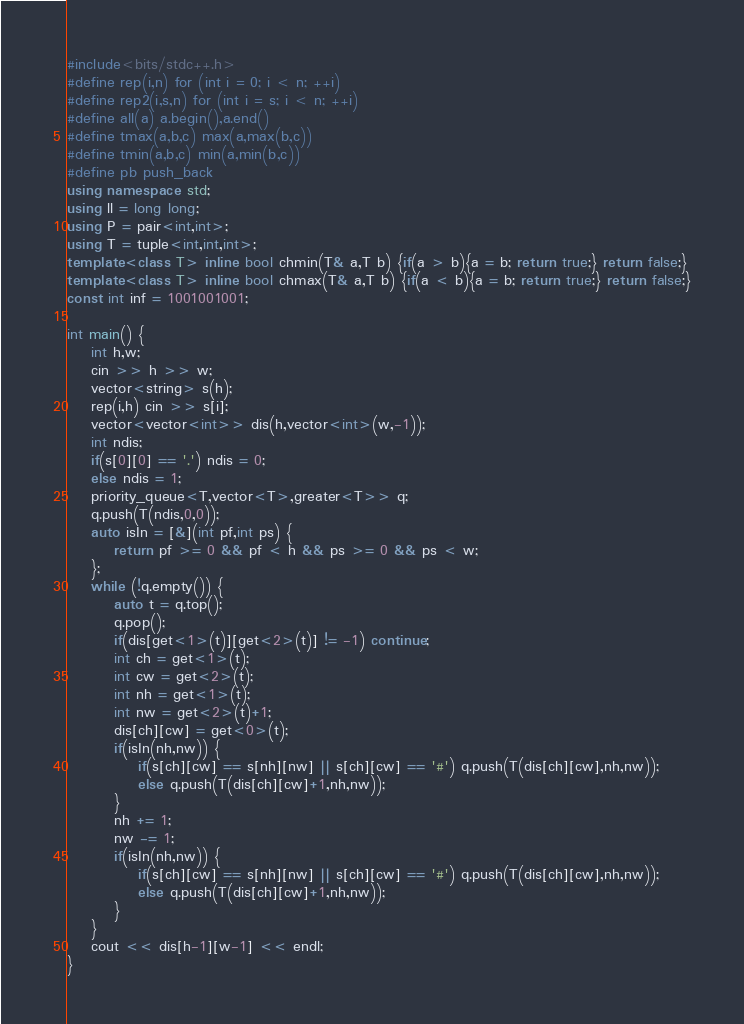Convert code to text. <code><loc_0><loc_0><loc_500><loc_500><_C++_>#include<bits/stdc++.h>
#define rep(i,n) for (int i = 0; i < n; ++i)
#define rep2(i,s,n) for (int i = s; i < n; ++i)
#define all(a) a.begin(),a.end()
#define tmax(a,b,c) max(a,max(b,c))
#define tmin(a,b,c) min(a,min(b,c))
#define pb push_back
using namespace std;
using ll = long long;
using P = pair<int,int>;
using T = tuple<int,int,int>;
template<class T> inline bool chmin(T& a,T b) {if(a > b){a = b; return true;} return false;}
template<class T> inline bool chmax(T& a,T b) {if(a < b){a = b; return true;} return false;}
const int inf = 1001001001;

int main() {
    int h,w;
    cin >> h >> w;
    vector<string> s(h);
    rep(i,h) cin >> s[i];
    vector<vector<int>> dis(h,vector<int>(w,-1));
    int ndis;
    if(s[0][0] == '.') ndis = 0;
    else ndis = 1;
    priority_queue<T,vector<T>,greater<T>> q;
    q.push(T(ndis,0,0));
    auto isIn = [&](int pf,int ps) {
        return pf >= 0 && pf < h && ps >= 0 && ps < w;
    };
    while (!q.empty()) {
        auto t = q.top();
        q.pop();
        if(dis[get<1>(t)][get<2>(t)] != -1) continue;
        int ch = get<1>(t);
        int cw = get<2>(t);
        int nh = get<1>(t);
        int nw = get<2>(t)+1;
        dis[ch][cw] = get<0>(t);
        if(isIn(nh,nw)) {
            if(s[ch][cw] == s[nh][nw] || s[ch][cw] == '#') q.push(T(dis[ch][cw],nh,nw));
            else q.push(T(dis[ch][cw]+1,nh,nw));
        }
        nh += 1;
        nw -= 1;
        if(isIn(nh,nw)) {
            if(s[ch][cw] == s[nh][nw] || s[ch][cw] == '#') q.push(T(dis[ch][cw],nh,nw));
            else q.push(T(dis[ch][cw]+1,nh,nw));
        }
    }
    cout << dis[h-1][w-1] << endl;
}</code> 